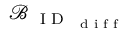<formula> <loc_0><loc_0><loc_500><loc_500>\mathcal { B } _ { { I D } _ { d i f f } }</formula> 